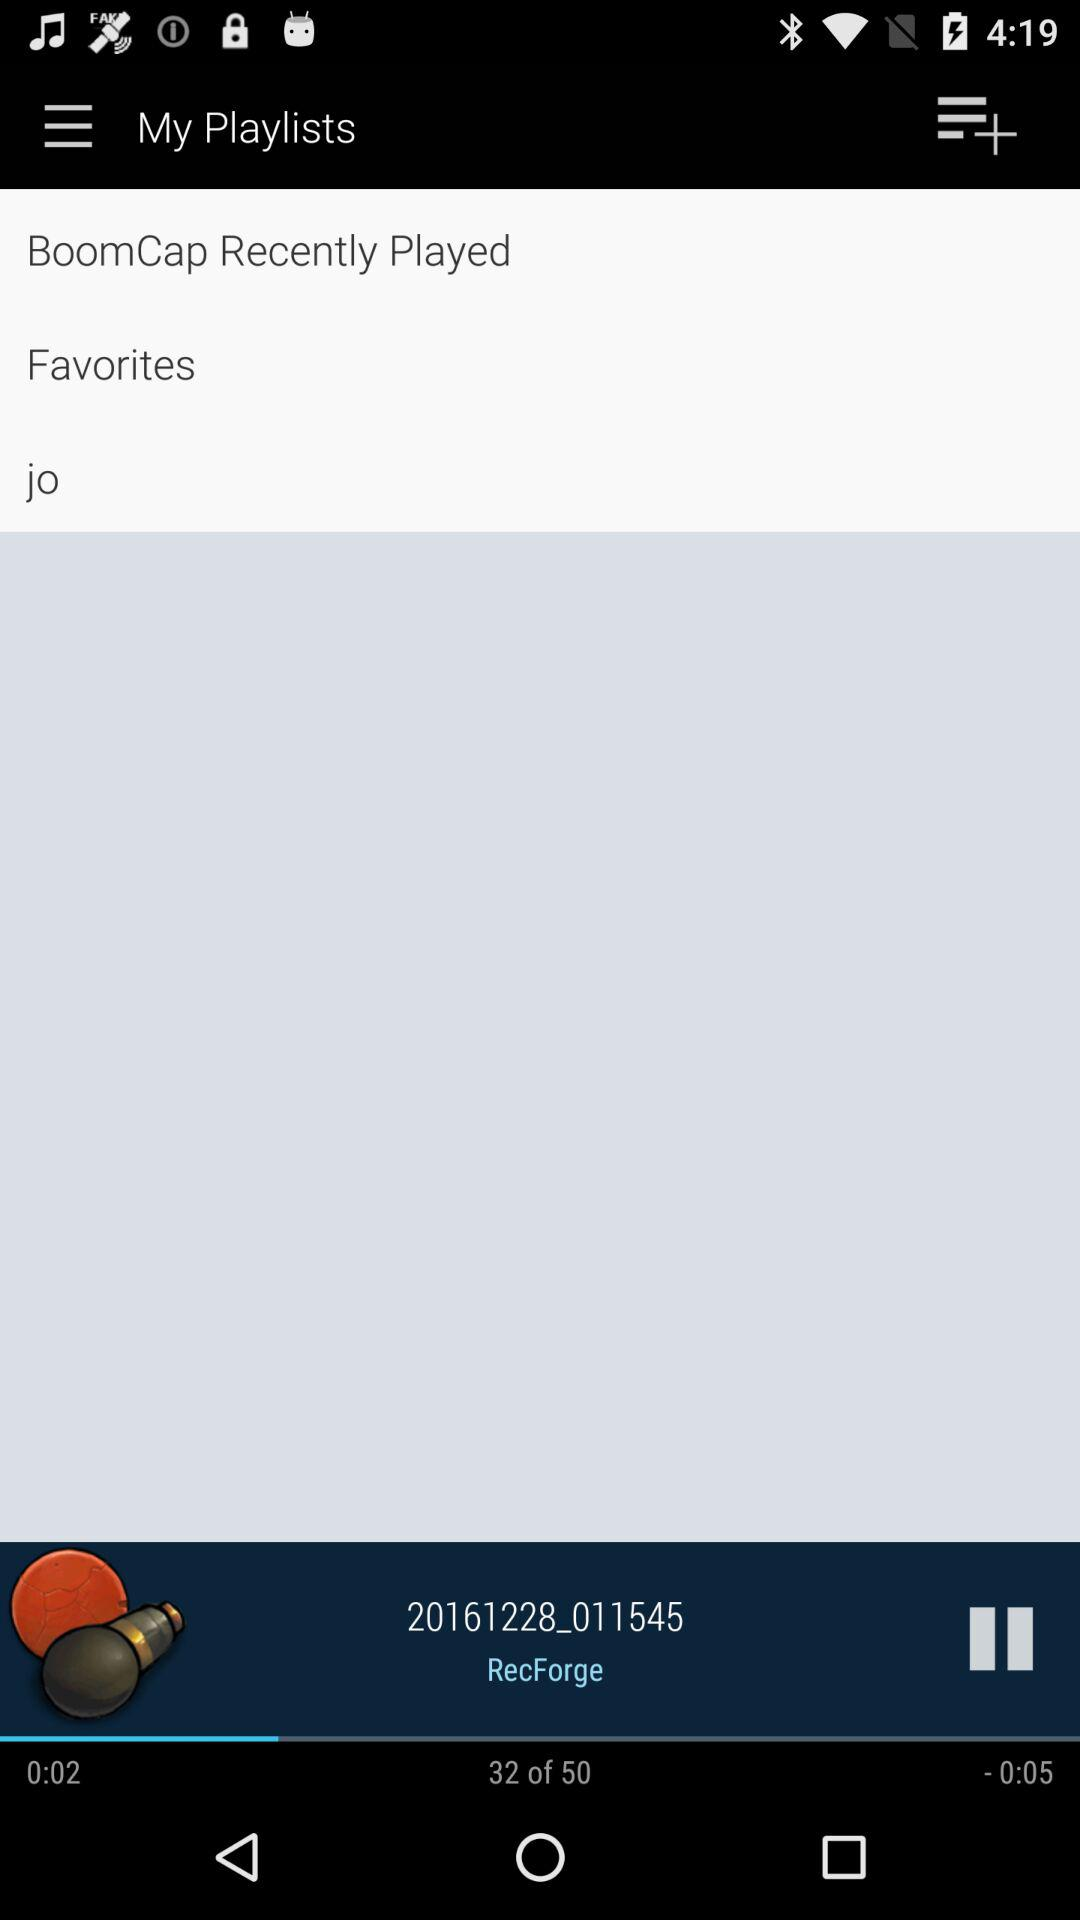Which recording am I on? You are on recording number 32. 